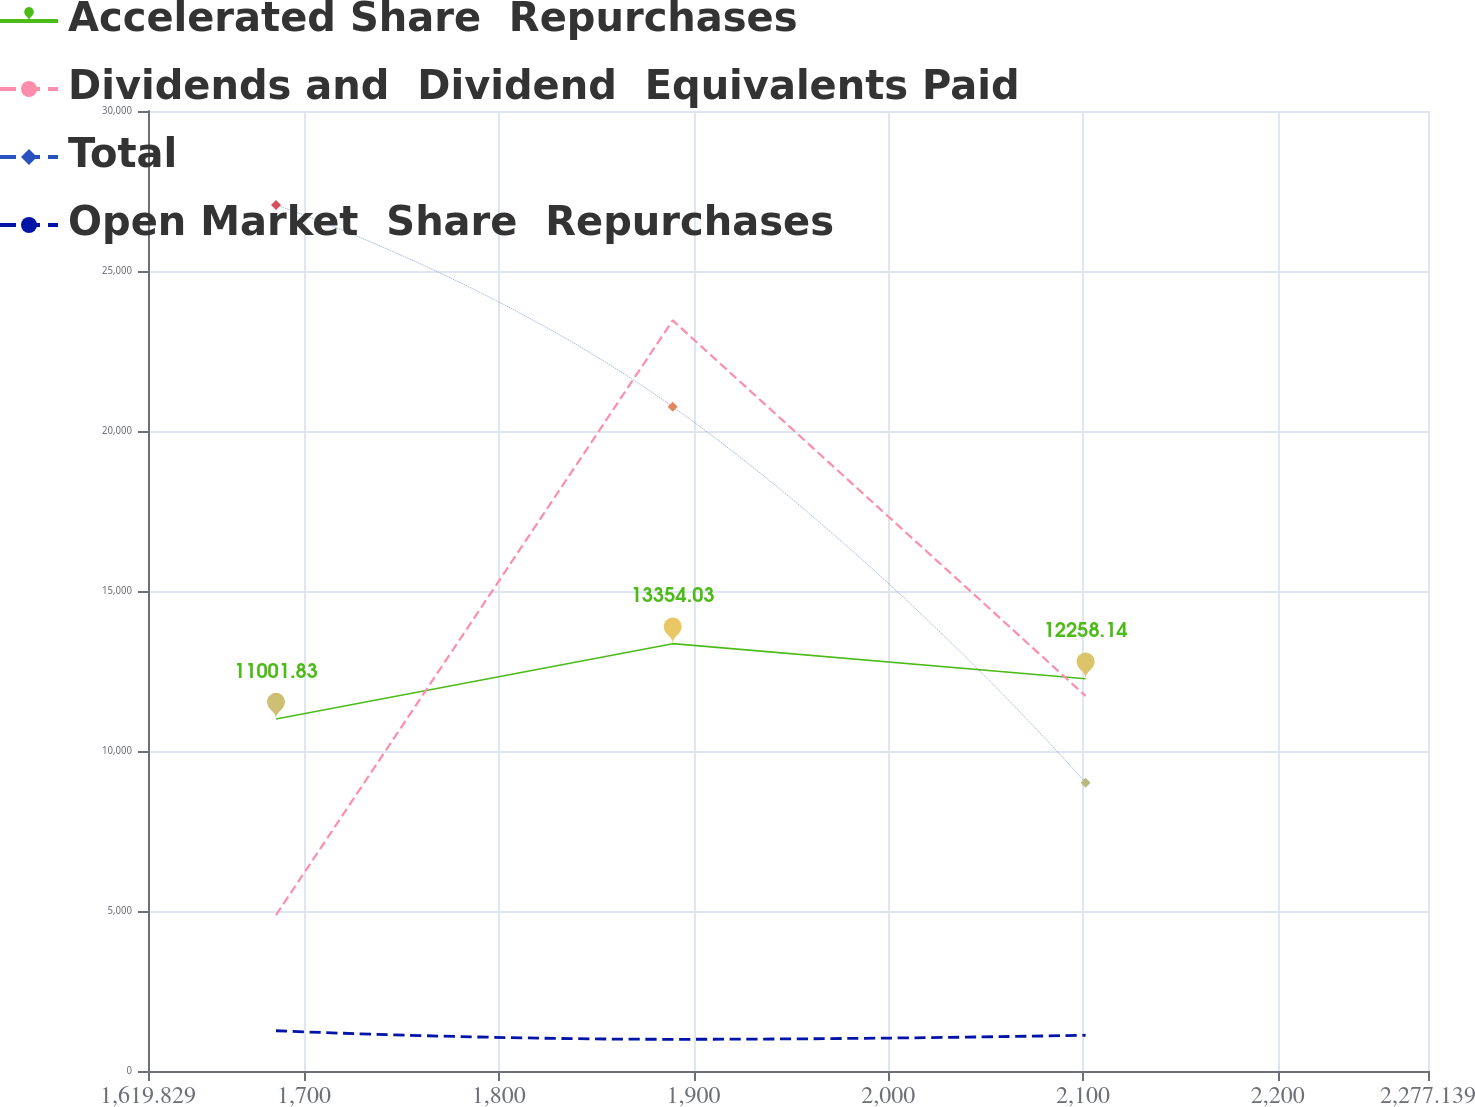Convert chart. <chart><loc_0><loc_0><loc_500><loc_500><line_chart><ecel><fcel>Accelerated Share  Repurchases<fcel>Dividends and  Dividend  Equivalents Paid<fcel>Total<fcel>Open Market  Share  Repurchases<nl><fcel>1685.56<fcel>11001.8<fcel>4874.39<fcel>27063.4<fcel>1257.79<nl><fcel>1889.28<fcel>13354<fcel>23456.1<fcel>20758.1<fcel>990.89<nl><fcel>2101.3<fcel>12258.1<fcel>11720.9<fcel>9008.22<fcel>1117.82<nl><fcel>2342.87<fcel>2165.81<fcel>0<fcel>0<fcel>51.81<nl></chart> 